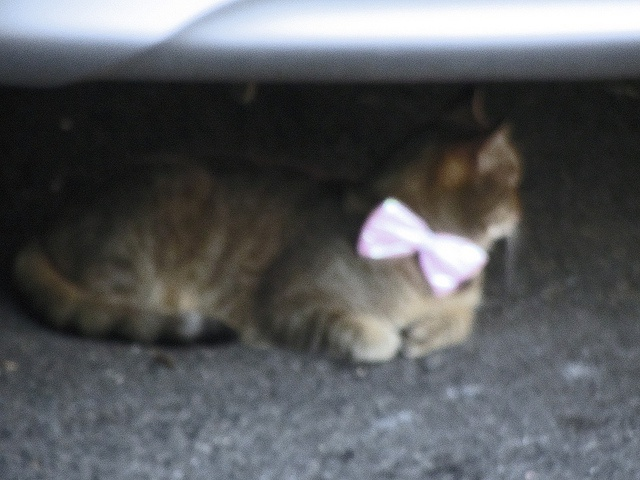Describe the objects in this image and their specific colors. I can see cat in lightblue, black, gray, and darkgray tones and tie in lightblue, lavender, pink, and darkgray tones in this image. 